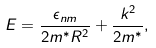Convert formula to latex. <formula><loc_0><loc_0><loc_500><loc_500>E = \frac { \epsilon _ { n m } } { 2 m ^ { * } R ^ { 2 } } + \frac { k ^ { 2 } } { 2 m ^ { * } } ,</formula> 